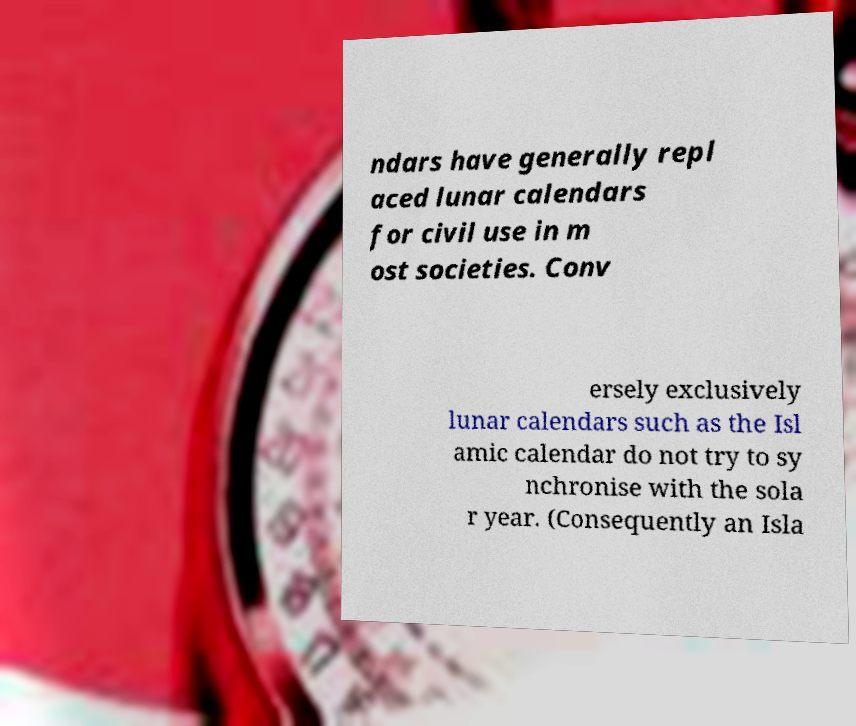For documentation purposes, I need the text within this image transcribed. Could you provide that? ndars have generally repl aced lunar calendars for civil use in m ost societies. Conv ersely exclusively lunar calendars such as the Isl amic calendar do not try to sy nchronise with the sola r year. (Consequently an Isla 